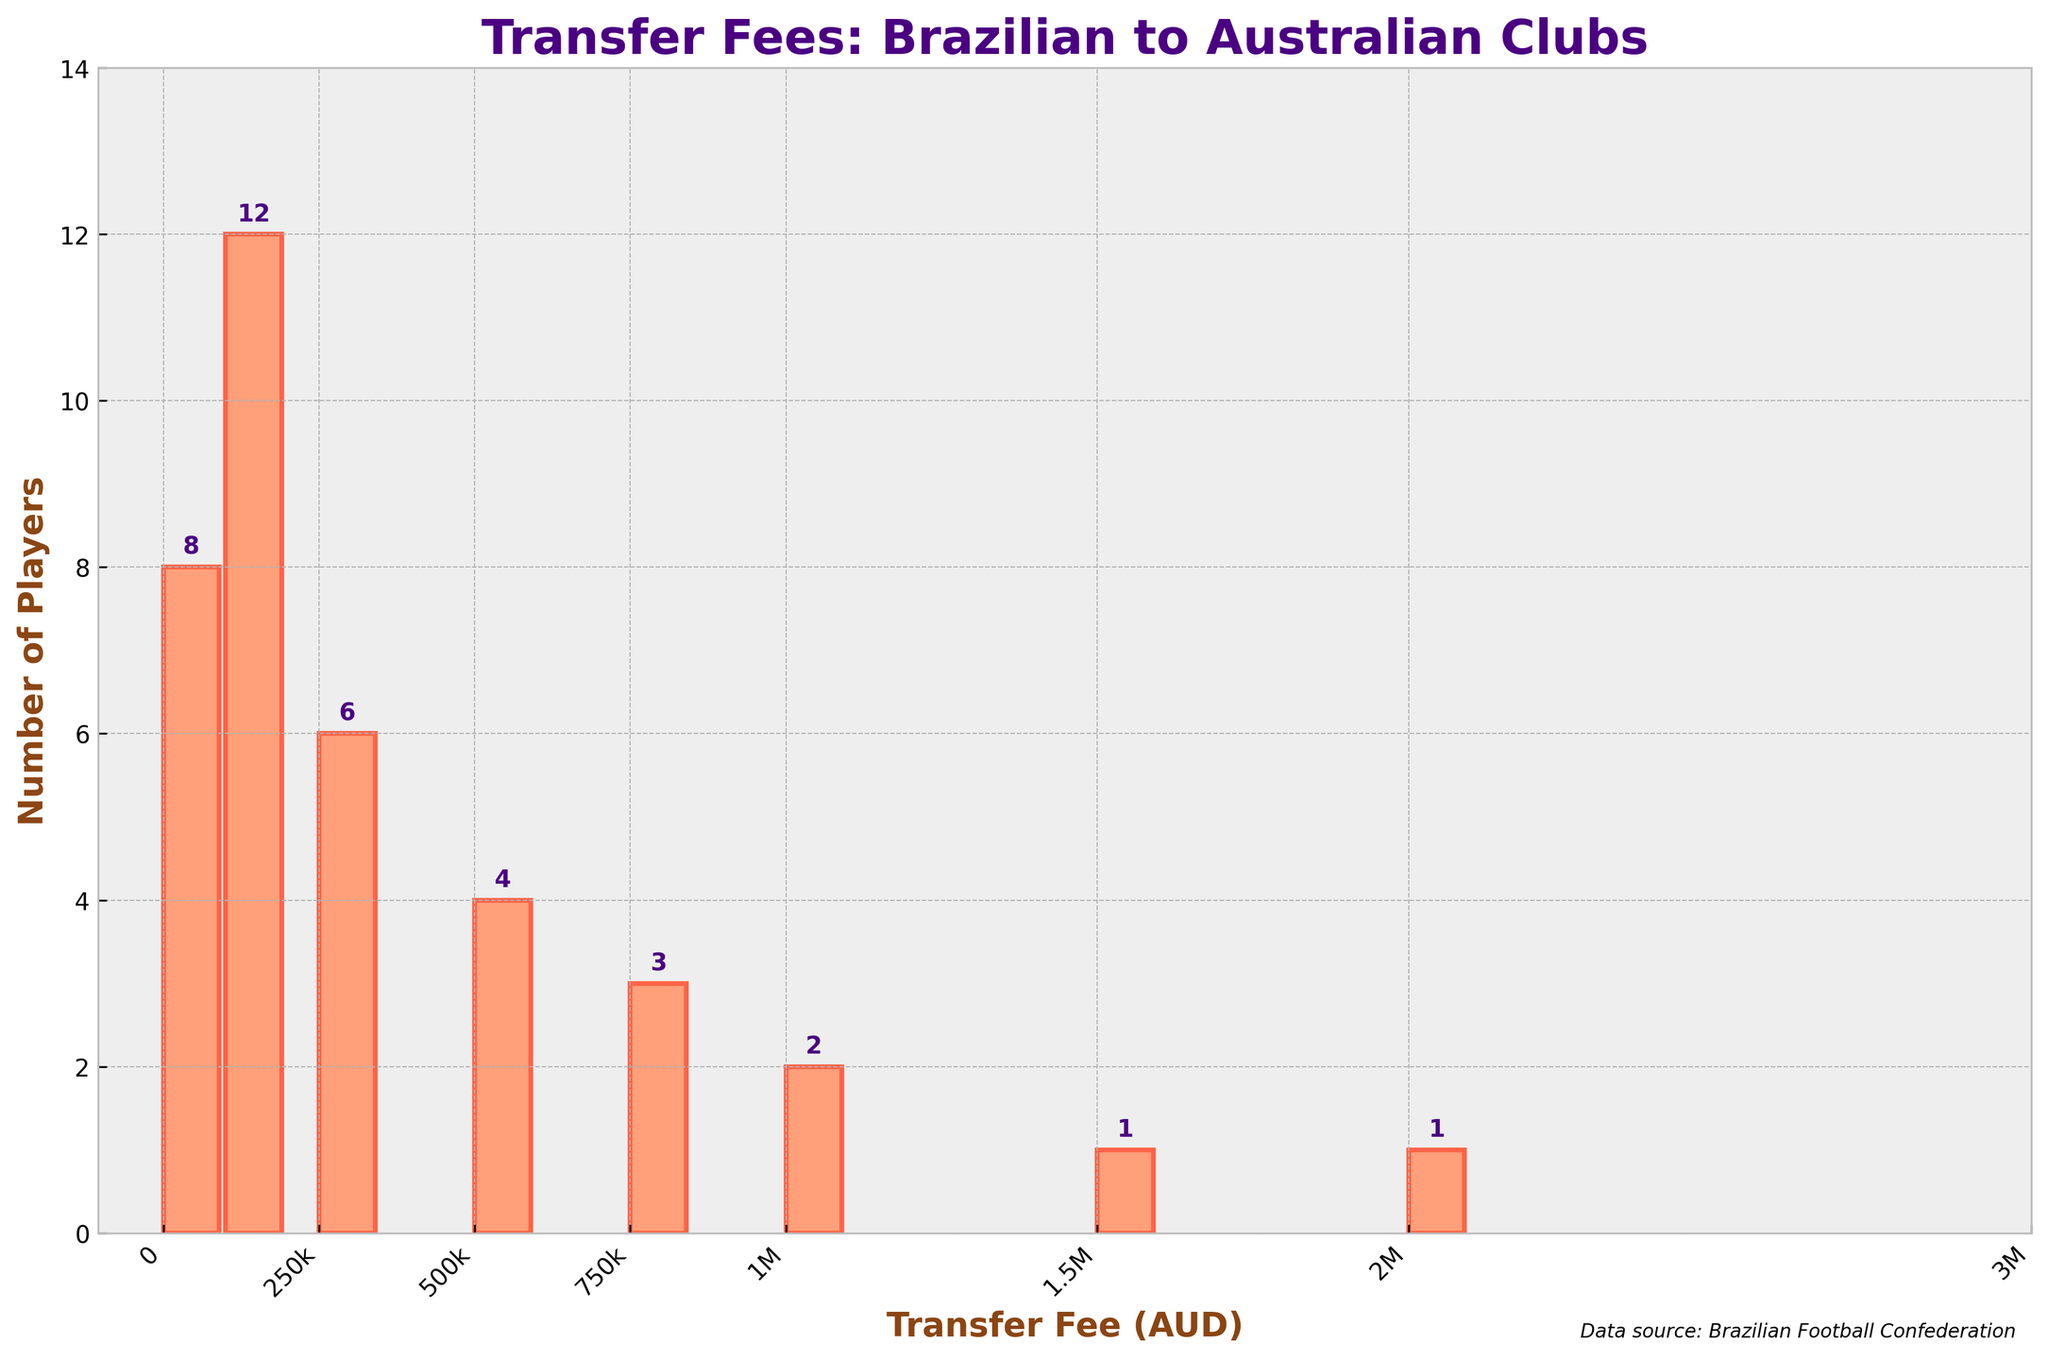What is the title of the histogram? The title of the histogram is displayed at the top of the figure.
Answer: Transfer Fees: Brazilian to Australian Clubs What is the total number of players transferred? Sum up all the values from the 'Number of Players' column: 8 + 12 + 6 + 4 + 3 + 2 + 1 + 1 = 37.
Answer: 37 How many transfer fee ranges are there in the histogram? Count the number of distinct bars or ranges on the x-axis.
Answer: 8 Which transfer fee range has the highest number of players? Identify the bar with the greatest height. The range '100001-250000' has the highest number of players at 12.
Answer: 100001-250000 How many players were transferred for fees between 500001 and 1000000 AUD? Add the numbers of players in the 500001-750000 and 750001-1000000 ranges: 4 + 3 = 7.
Answer: 7 Which transfer fee range has the least number of transferred players? Identify the bar with the shortest height. Both '1500001-2000000' and '2000001-3000000' have 1 player each.
Answer: 1500001-2000000 and 2000001-3000000 What is the average number of players transferred per fee range? Divide the total number of players by the number of fee ranges: 37 / 8 ≈ 4.625.
Answer: 4.625 Are there more players transferred for less than 500000 AUD or more than 500000 AUD? Sum the numbers of players in ranges below 500000: 8 + 12 + 6 = 26, and compare it to players in ranges above 500000: 4 + 3 + 2 + 1 + 1 = 11. There are more players transferred for less than 500000 AUD.
Answer: Less than 500000 AUD Which fee range is more popular: 250001-500000 or 500001-750000? Compare the number of players in each range: 6 for 250001-500000 and 4 for 500001-750000.
Answer: 250001-500000 What is the range of the y-axis on the histogram? The y-axis represents the number of players, which ranges from 0 to slightly above the highest bar count plus a small buffer. The highest count is 12, so the y-axis goes up to approximately 14.
Answer: 0 to 14 